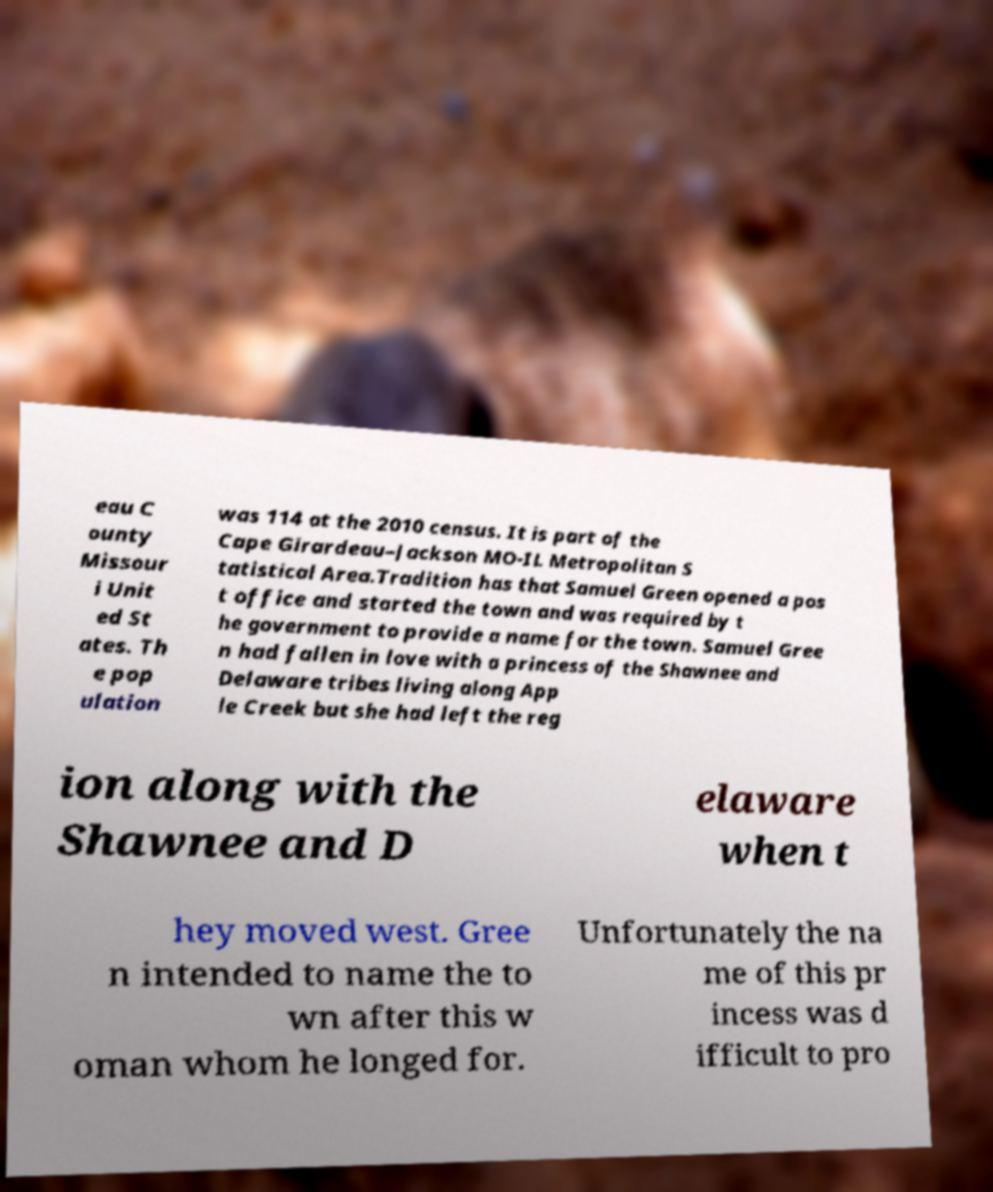For documentation purposes, I need the text within this image transcribed. Could you provide that? eau C ounty Missour i Unit ed St ates. Th e pop ulation was 114 at the 2010 census. It is part of the Cape Girardeau–Jackson MO-IL Metropolitan S tatistical Area.Tradition has that Samuel Green opened a pos t office and started the town and was required by t he government to provide a name for the town. Samuel Gree n had fallen in love with a princess of the Shawnee and Delaware tribes living along App le Creek but she had left the reg ion along with the Shawnee and D elaware when t hey moved west. Gree n intended to name the to wn after this w oman whom he longed for. Unfortunately the na me of this pr incess was d ifficult to pro 